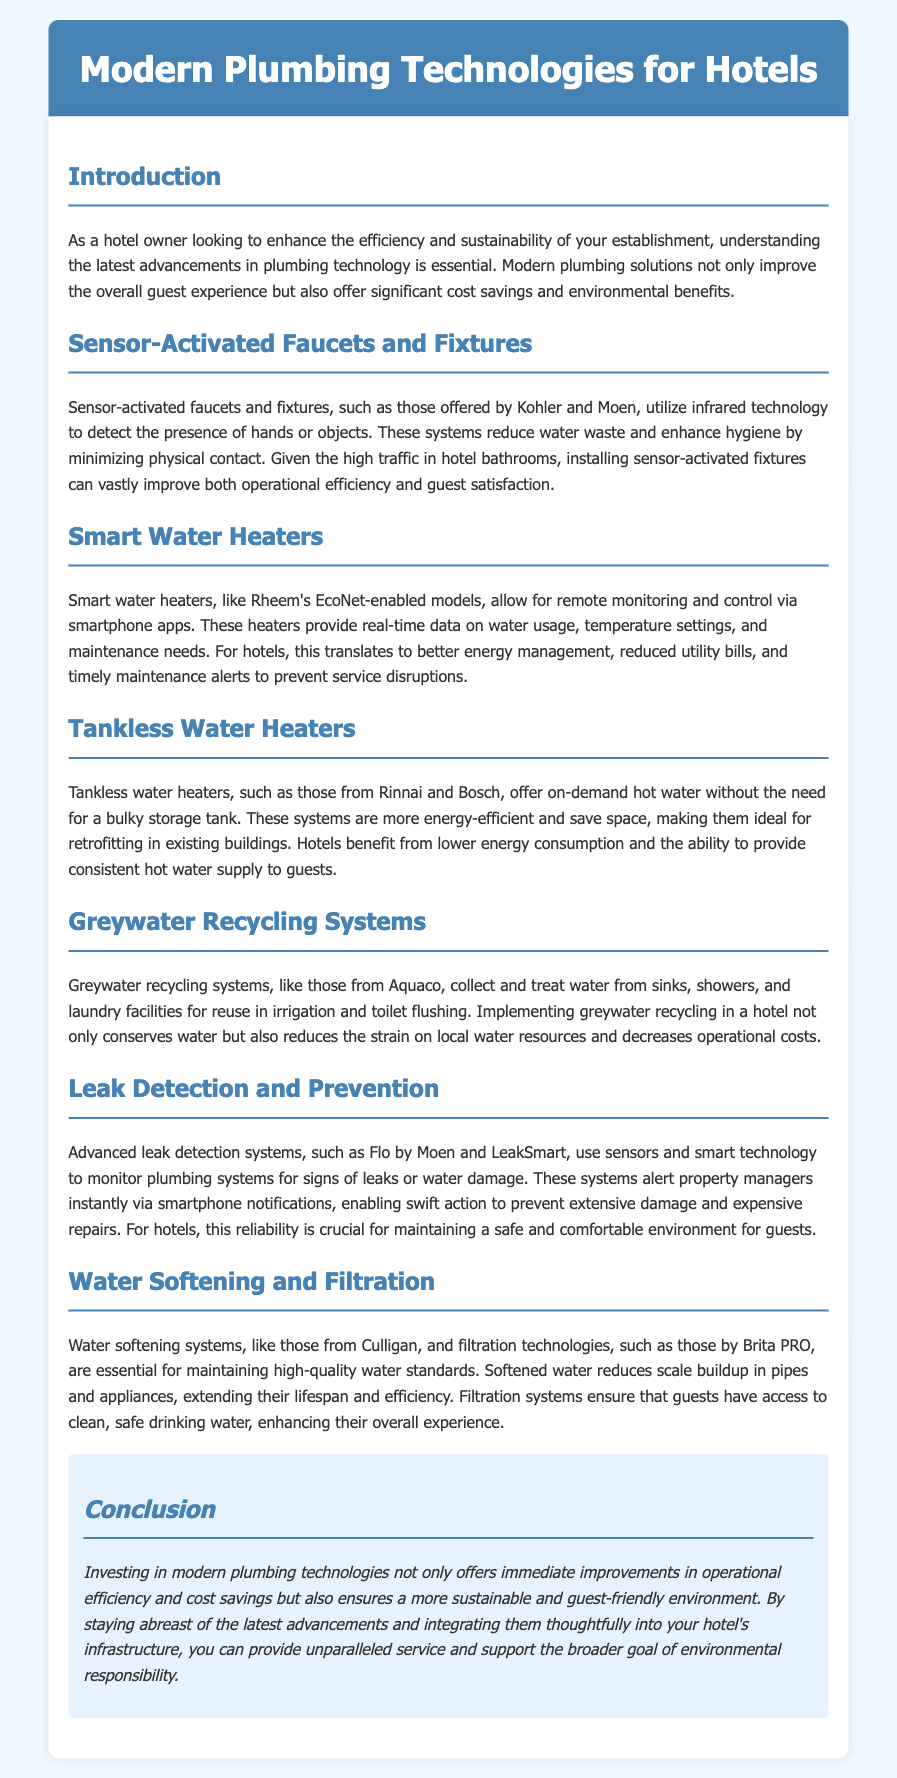What is the title of the document? The document is titled "Modern Plumbing Technologies for Hotels."
Answer: Modern Plumbing Technologies for Hotels What technology reduces water waste in hotel bathrooms? Sensor-activated faucets and fixtures utilize infrared technology to detect presence, reducing water waste.
Answer: Sensor-activated faucets and fixtures Which company produces EcoNet-enabled smart water heaters? Rheem manufactures EcoNet-enabled smart water heaters.
Answer: Rheem What type of water heater is more energy-efficient and saves space? Tankless water heaters provide on-demand hot water without a bulky storage tank.
Answer: Tankless water heaters What is the purpose of greywater recycling systems? Greywater recycling systems collect and treat water for reuse in irrigation and toilet flushing.
Answer: Reuse in irrigation and toilet flushing What do advanced leak detection systems do? They monitor plumbing systems for leaks and alert property managers instantly via smartphone.
Answer: Monitor plumbing systems for leaks What is the benefit of water softening systems? Water softening systems reduce scale buildup in pipes, extending lifespan and efficiency.
Answer: Reduce scale buildup What is the conclusion about investing in modern plumbing technologies? Investing in modern plumbing technologies ensures a sustainable and guest-friendly environment.
Answer: Sustainable and guest-friendly environment 